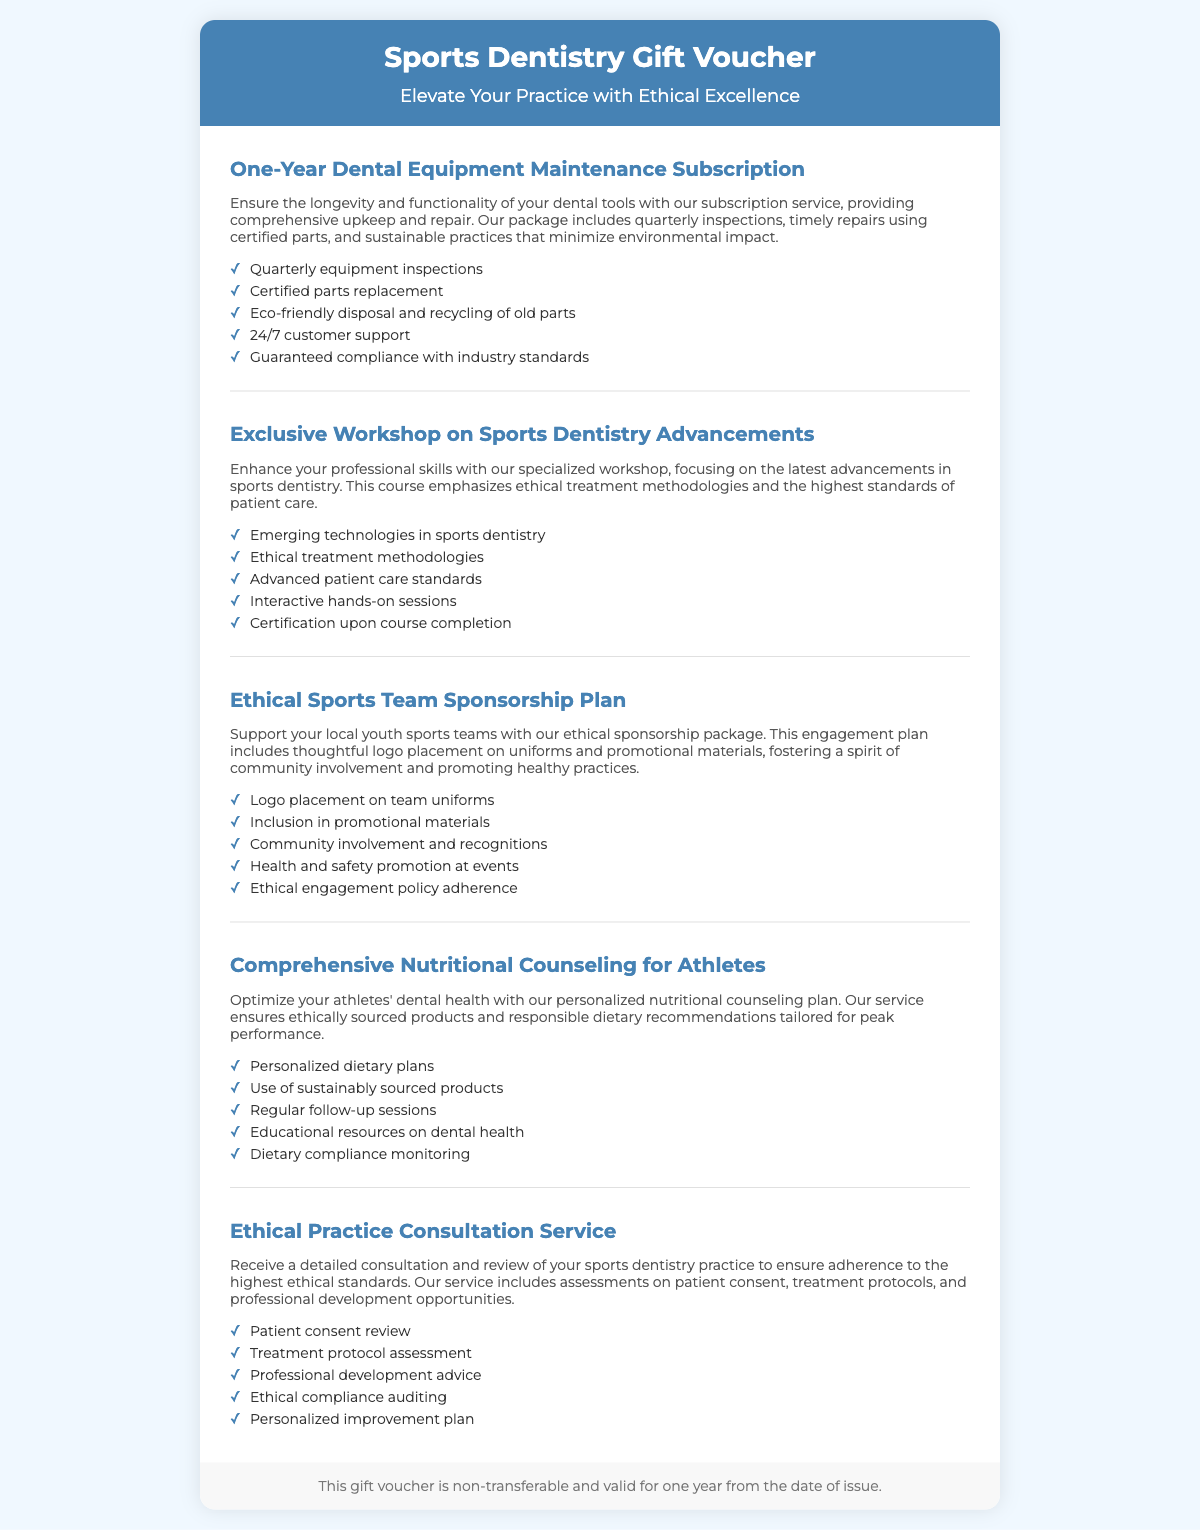What is the title of the gift voucher? The title of the voucher is located at the top of the document.
Answer: Sports Dentistry Gift Voucher What year does the dental equipment maintenance package cover? The duration of the subscription is mentioned in the first gift item description.
Answer: One-year How many inspections are included in the dental equipment maintenance package? The number of inspections is detailed in the features list of the first gift item.
Answer: Quarterly What type of course does the voucher include? The second gift item describes the nature of the course being offered.
Answer: Workshop on Sports Dentistry Advancements Which ethical aspect does the sponsorship package emphasize? The gift description of the third item highlights a specific ethical consideration.
Answer: Community involvement What will the nutritional counseling plan focus on? The focus of the personalized nutritional counseling plan is mentioned in the description of the fourth gift item.
Answer: Optimal dental health What type of review does the ethical practice consultation service provide? The nature of the consultation is specified in the description of the fifth gift item.
Answer: Detailed consultation and review Is the gift voucher transferable? The transferability of the voucher is stated in the footer of the document.
Answer: Non-transferable What should be used for replacements in the dental equipment maintenance package? The features list mentions what parts should be used for repairs.
Answer: Certified parts 